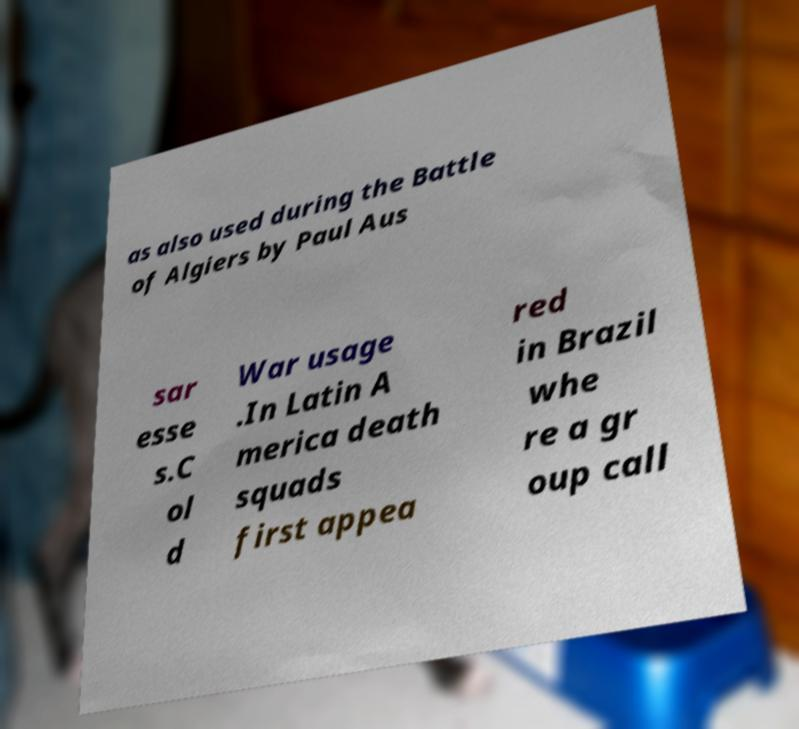Please identify and transcribe the text found in this image. as also used during the Battle of Algiers by Paul Aus sar esse s.C ol d War usage .In Latin A merica death squads first appea red in Brazil whe re a gr oup call 